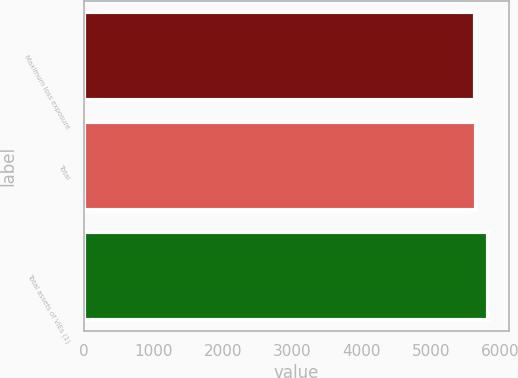Convert chart. <chart><loc_0><loc_0><loc_500><loc_500><bar_chart><fcel>Maximum loss exposure<fcel>Total<fcel>Total assets of VIEs (1)<nl><fcel>5634<fcel>5653.5<fcel>5829<nl></chart> 